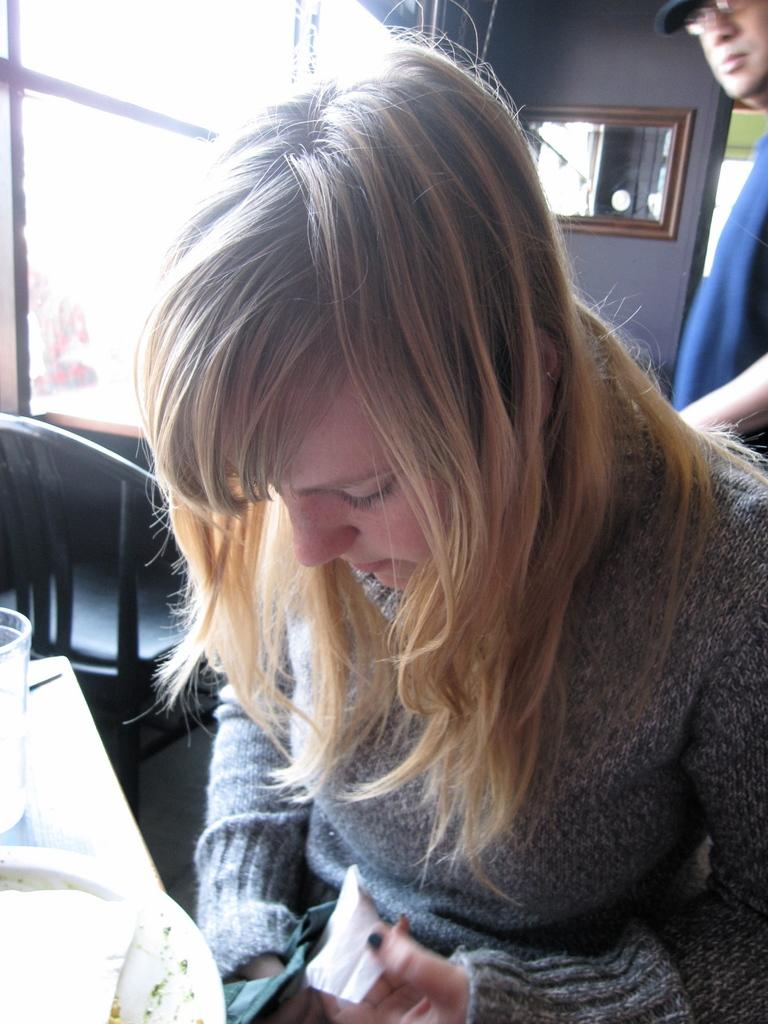What is the girl in the image doing? The girl is sitting in the image. What objects are in front of the girl? There is a glass and a plate in front of the girl. What can be seen in the background of the image? There is a window, a mirror on the wall, a chair, and a man in the background. What type of clouds can be seen through the window in the image? There is no mention of clouds in the image, as the background only includes a window, a mirror on the wall, a chair, and a man. 